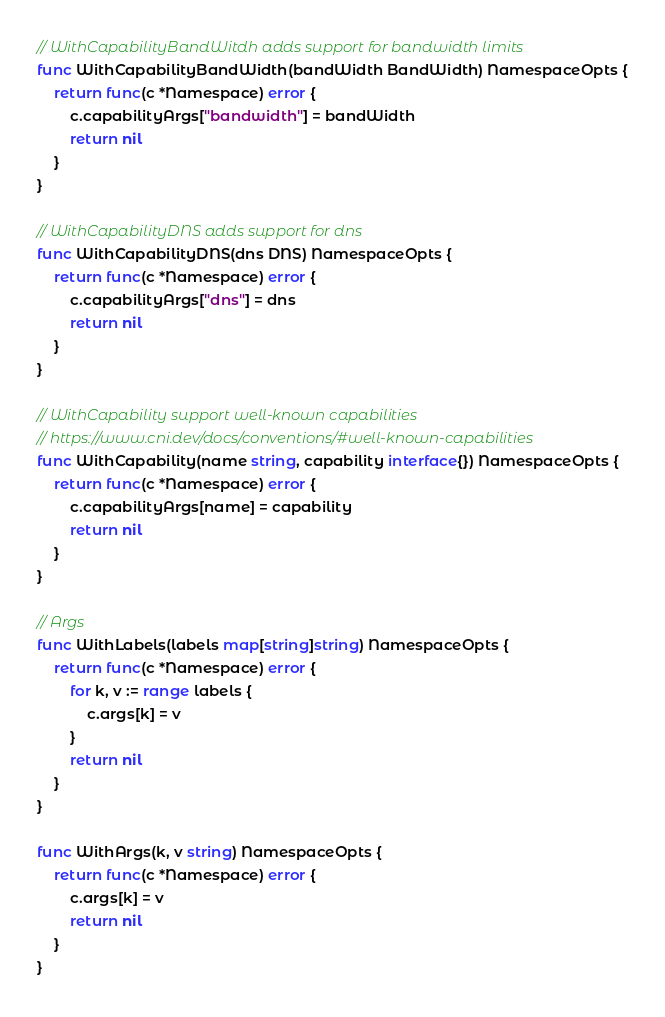Convert code to text. <code><loc_0><loc_0><loc_500><loc_500><_Go_>
// WithCapabilityBandWitdh adds support for bandwidth limits
func WithCapabilityBandWidth(bandWidth BandWidth) NamespaceOpts {
	return func(c *Namespace) error {
		c.capabilityArgs["bandwidth"] = bandWidth
		return nil
	}
}

// WithCapabilityDNS adds support for dns
func WithCapabilityDNS(dns DNS) NamespaceOpts {
	return func(c *Namespace) error {
		c.capabilityArgs["dns"] = dns
		return nil
	}
}

// WithCapability support well-known capabilities
// https://www.cni.dev/docs/conventions/#well-known-capabilities
func WithCapability(name string, capability interface{}) NamespaceOpts {
	return func(c *Namespace) error {
		c.capabilityArgs[name] = capability
		return nil
	}
}

// Args
func WithLabels(labels map[string]string) NamespaceOpts {
	return func(c *Namespace) error {
		for k, v := range labels {
			c.args[k] = v
		}
		return nil
	}
}

func WithArgs(k, v string) NamespaceOpts {
	return func(c *Namespace) error {
		c.args[k] = v
		return nil
	}
}
</code> 